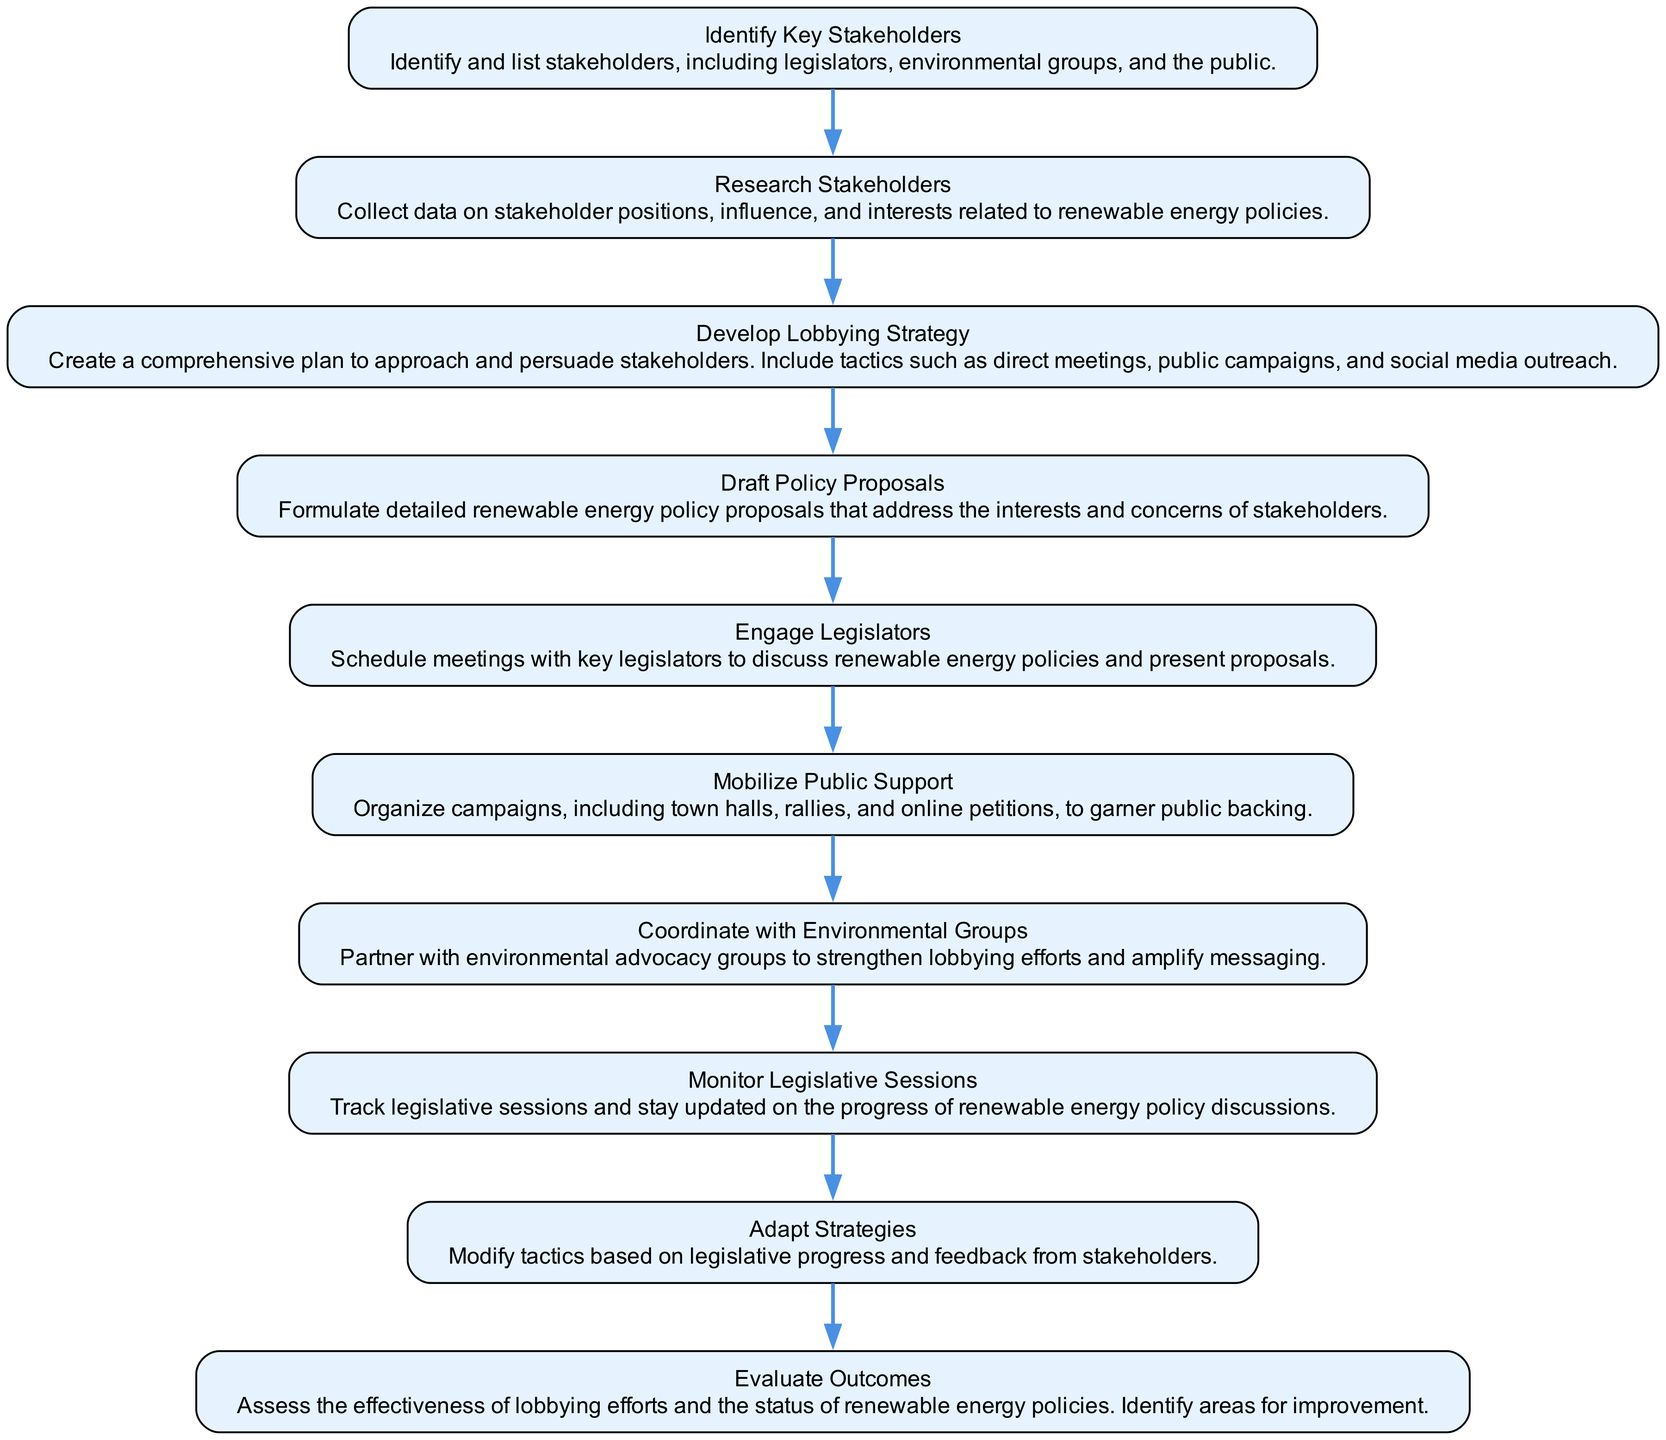What is the first activity in the diagram? The first activity is "Identify Key Stakeholders", which is the starting point of the lobbying process in the diagram.
Answer: Identify Key Stakeholders How many activities are listed in the diagram? There are a total of ten activities presented in the diagram related to the lobbying process for renewable energy policies.
Answer: Ten What activity directly follows "Mobilize Public Support"? The activity that directly follows "Mobilize Public Support" is "Coordinate with Environmental Groups". This shows the progression from gaining public support to collaborating with advocacy organizations.
Answer: Coordinate with Environmental Groups Which activity involves tracking legislative sessions? The activity that involves tracking legislative sessions is "Monitor Legislative Sessions". This activity is crucial for staying informed about legislative progress regarding renewable energy.
Answer: Monitor Legislative Sessions Which two activities deal with strategy development? The two activities that deal with strategy development are "Develop Lobbying Strategy" and "Adapt Strategies". The first focuses on creating a plan, while the second adjusts that plan based on feedback.
Answer: Develop Lobbying Strategy, Adapt Strategies What is the last activity in the diagram? The last activity in the diagram is "Evaluate Outcomes", which is where the effectiveness of lobbying efforts and policies is assessed for future improvements.
Answer: Evaluate Outcomes How do "Engage Legislators" and "Mobilize Public Support" relate in the flow? "Engage Legislators" directly follows "Mobilize Public Support" in the sequence, indicating that after gaining public backing, engagement with lawmakers is the next step to push for policy changes.
Answer: Engage Legislators follows Mobilize Public Support What is the main purpose of the activity "Draft Policy Proposals"? The main purpose of "Draft Policy Proposals" is to create detailed policies that consider the interests and concerns of stakeholders, which is essential for effective lobbying.
Answer: Create detailed renewable energy policy proposals How does "Coordinate with Environmental Groups" enhance the lobbying process? "Coordinate with Environmental Groups" enhances the lobbying process by leveraging partnerships with advocacy organizations, which can amplify messaging and strengthen efforts towards achieving renewable energy policies.
Answer: Strengthen lobbying efforts and amplify messaging 